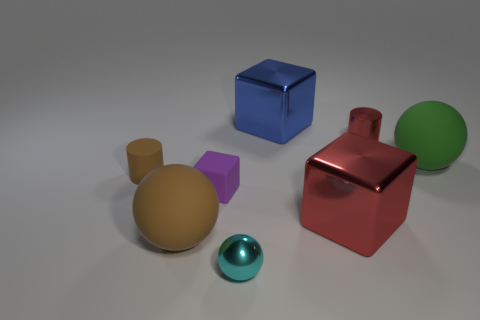The large block in front of the big cube that is behind the tiny thing to the left of the big brown rubber sphere is made of what material?
Offer a very short reply. Metal. There is a cube that is to the left of the blue cube; is its size the same as the tiny red thing?
Give a very brief answer. Yes. Are there more cyan matte cylinders than large blue metal things?
Offer a very short reply. No. How many big things are either brown rubber cylinders or matte blocks?
Ensure brevity in your answer.  0. How many other objects are the same color as the tiny sphere?
Keep it short and to the point. 0. What number of brown balls are made of the same material as the purple cube?
Your answer should be very brief. 1. There is a small thing on the left side of the tiny block; does it have the same color as the matte block?
Your answer should be compact. No. What number of brown things are cylinders or rubber cylinders?
Ensure brevity in your answer.  1. Are the cylinder on the left side of the big blue metallic cube and the large red object made of the same material?
Your response must be concise. No. What number of objects are either large yellow metal cubes or small things that are left of the big brown object?
Your answer should be compact. 1. 